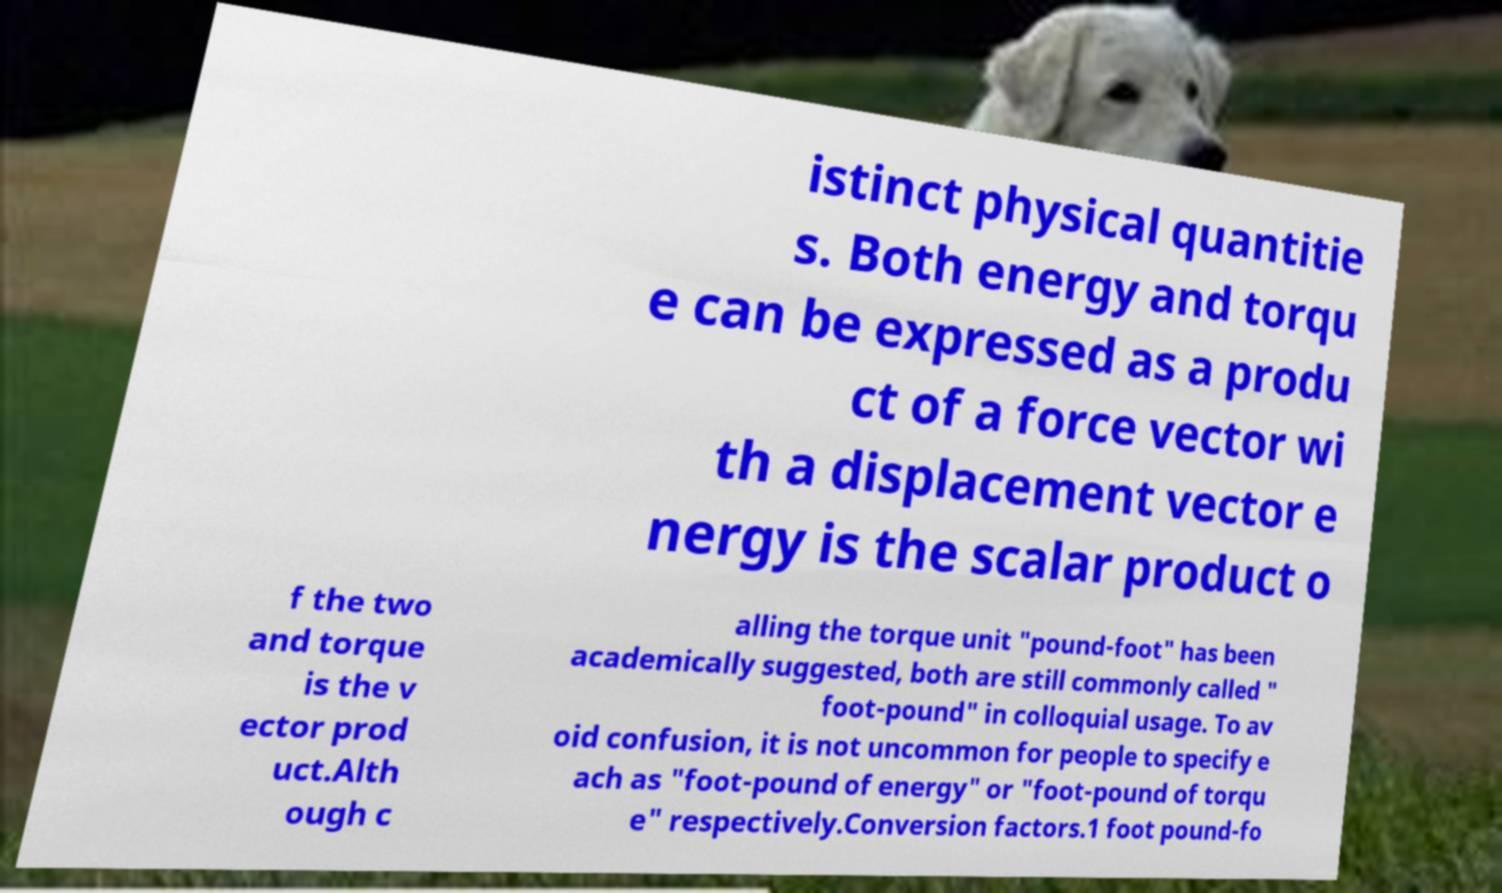Please identify and transcribe the text found in this image. istinct physical quantitie s. Both energy and torqu e can be expressed as a produ ct of a force vector wi th a displacement vector e nergy is the scalar product o f the two and torque is the v ector prod uct.Alth ough c alling the torque unit "pound-foot" has been academically suggested, both are still commonly called " foot-pound" in colloquial usage. To av oid confusion, it is not uncommon for people to specify e ach as "foot-pound of energy" or "foot-pound of torqu e" respectively.Conversion factors.1 foot pound-fo 